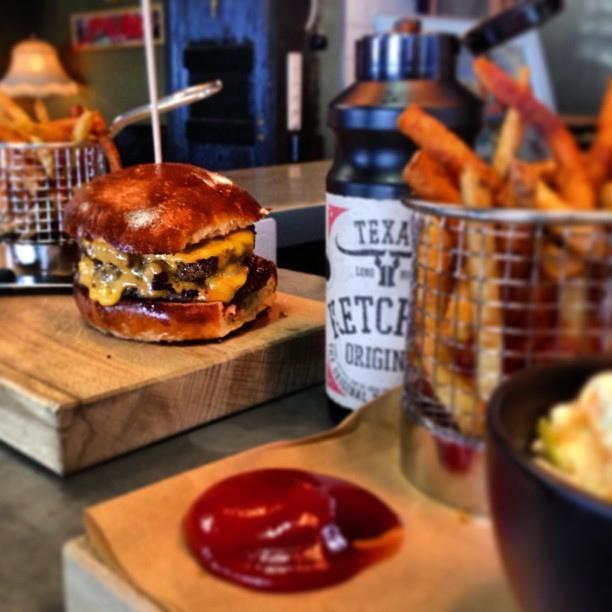Why is there a stick stuck in the cheeseburger?

Choices:
A) appearance
B) joke
C) hold together
D) check temp hold together 